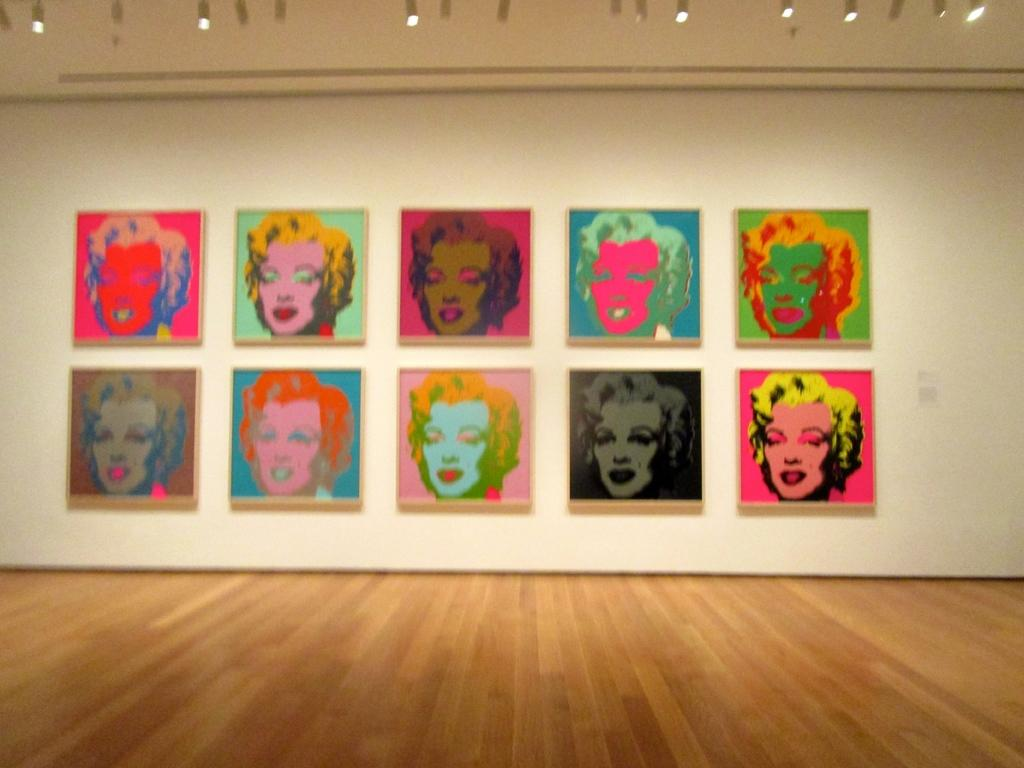What type of space is depicted in the image? The image shows an inner view of a room. What can be seen under the feet of the people in the room? There is a ground visible in the image. What decorative elements are present on the walls of the room? There are posters on the wall. What part of the room is visible at the top of the image? The roof of the room is visible. What is used to provide illumination in the room? There are lights on the roof. How many maids are present in the image? There is no mention of a maid in the image, so it cannot be determined how many are present. 